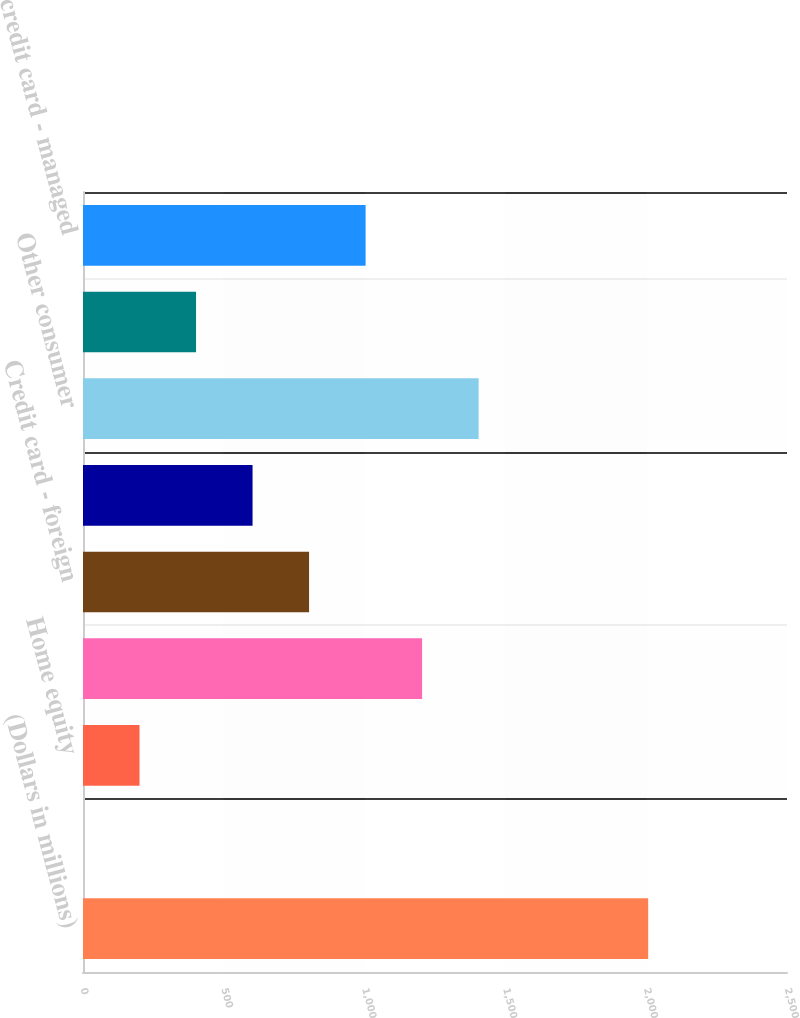Convert chart. <chart><loc_0><loc_0><loc_500><loc_500><bar_chart><fcel>(Dollars in millions)<fcel>Residential mortgage<fcel>Home equity<fcel>Credit card - domestic<fcel>Credit card - foreign<fcel>Direct/Indirect consumer<fcel>Other consumer<fcel>Total held<fcel>Total credit card - managed<nl><fcel>2007<fcel>0.02<fcel>200.72<fcel>1204.22<fcel>802.82<fcel>602.12<fcel>1404.92<fcel>401.42<fcel>1003.52<nl></chart> 